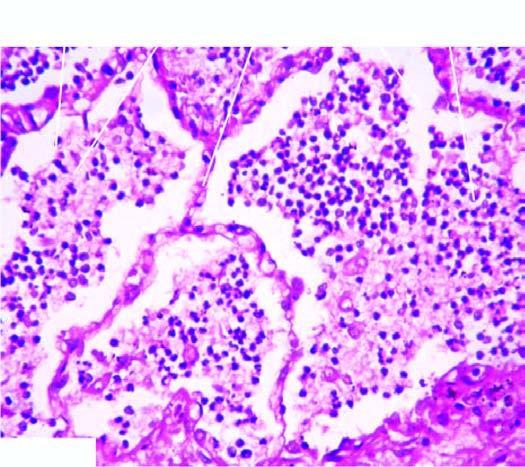s a wedge-shaped shrunken area of pale colour composed of neutrophils and macrophages?
Answer the question using a single word or phrase. No 